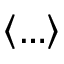Convert formula to latex. <formula><loc_0><loc_0><loc_500><loc_500>\left \langle \dots \right \rangle</formula> 